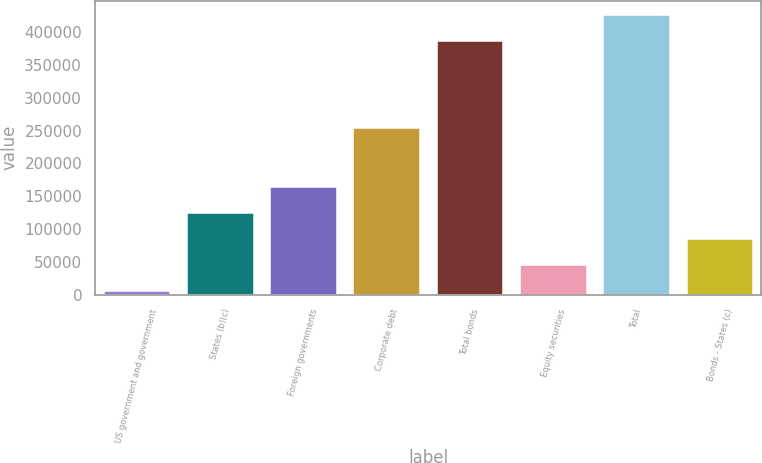<chart> <loc_0><loc_0><loc_500><loc_500><bar_chart><fcel>US government and government<fcel>States (b)(c)<fcel>Foreign governments<fcel>Corporate debt<fcel>Total bonds<fcel>Equity securities<fcel>Total<fcel>Bonds - States (c)<nl><fcel>5362<fcel>124554<fcel>164285<fcel>253731<fcel>386869<fcel>45092.8<fcel>426600<fcel>84823.6<nl></chart> 